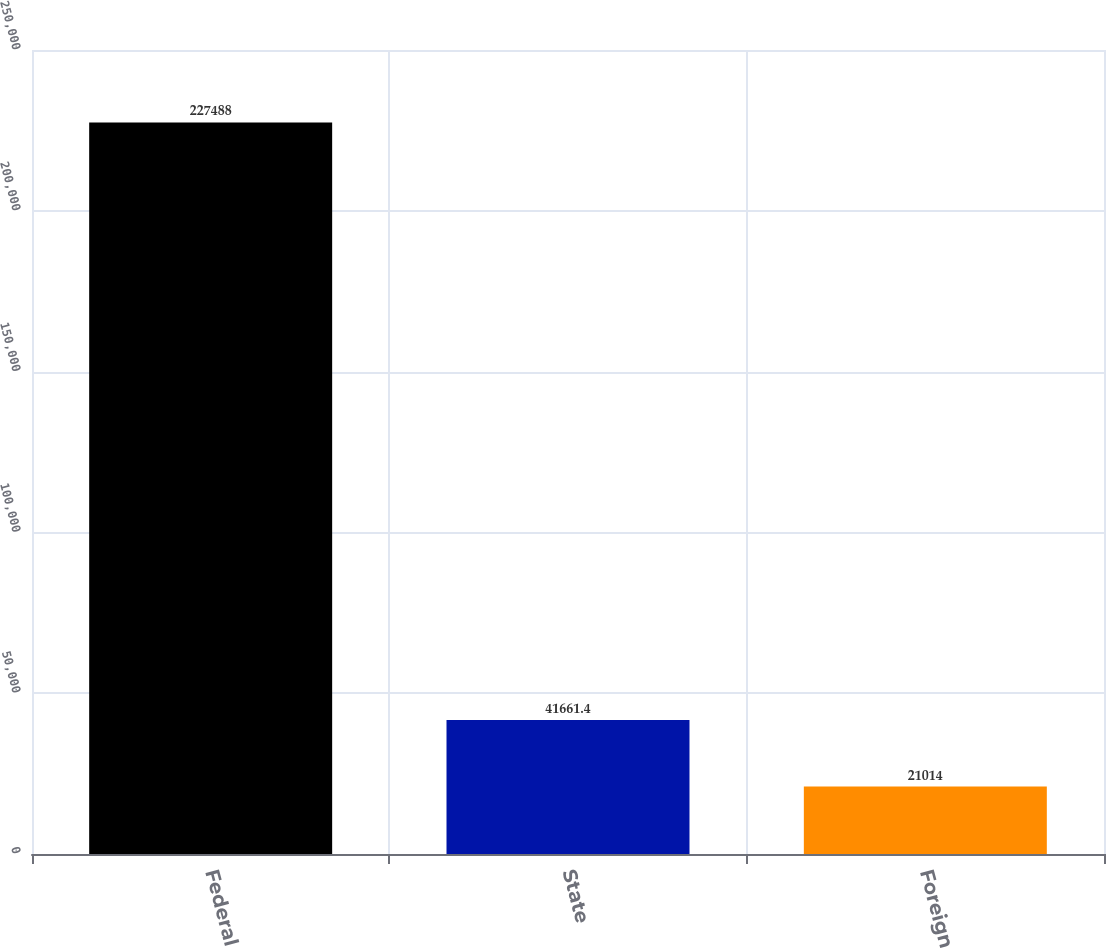Convert chart to OTSL. <chart><loc_0><loc_0><loc_500><loc_500><bar_chart><fcel>Federal<fcel>State<fcel>Foreign<nl><fcel>227488<fcel>41661.4<fcel>21014<nl></chart> 